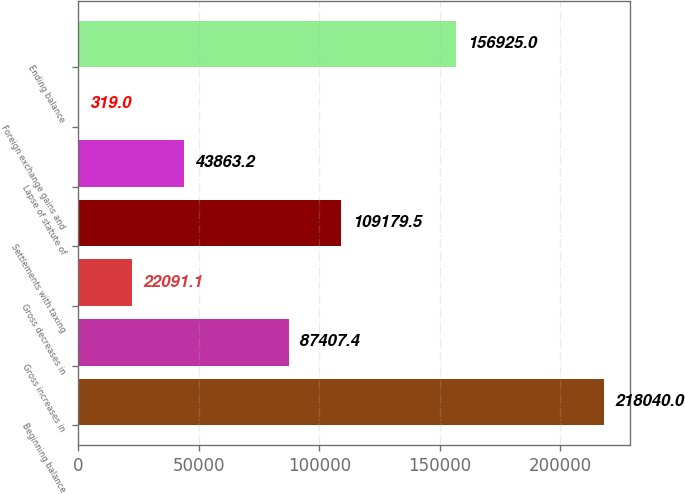Convert chart to OTSL. <chart><loc_0><loc_0><loc_500><loc_500><bar_chart><fcel>Beginning balance<fcel>Gross increases in<fcel>Gross decreases in<fcel>Settlements with taxing<fcel>Lapse of statute of<fcel>Foreign exchange gains and<fcel>Ending balance<nl><fcel>218040<fcel>87407.4<fcel>22091.1<fcel>109180<fcel>43863.2<fcel>319<fcel>156925<nl></chart> 